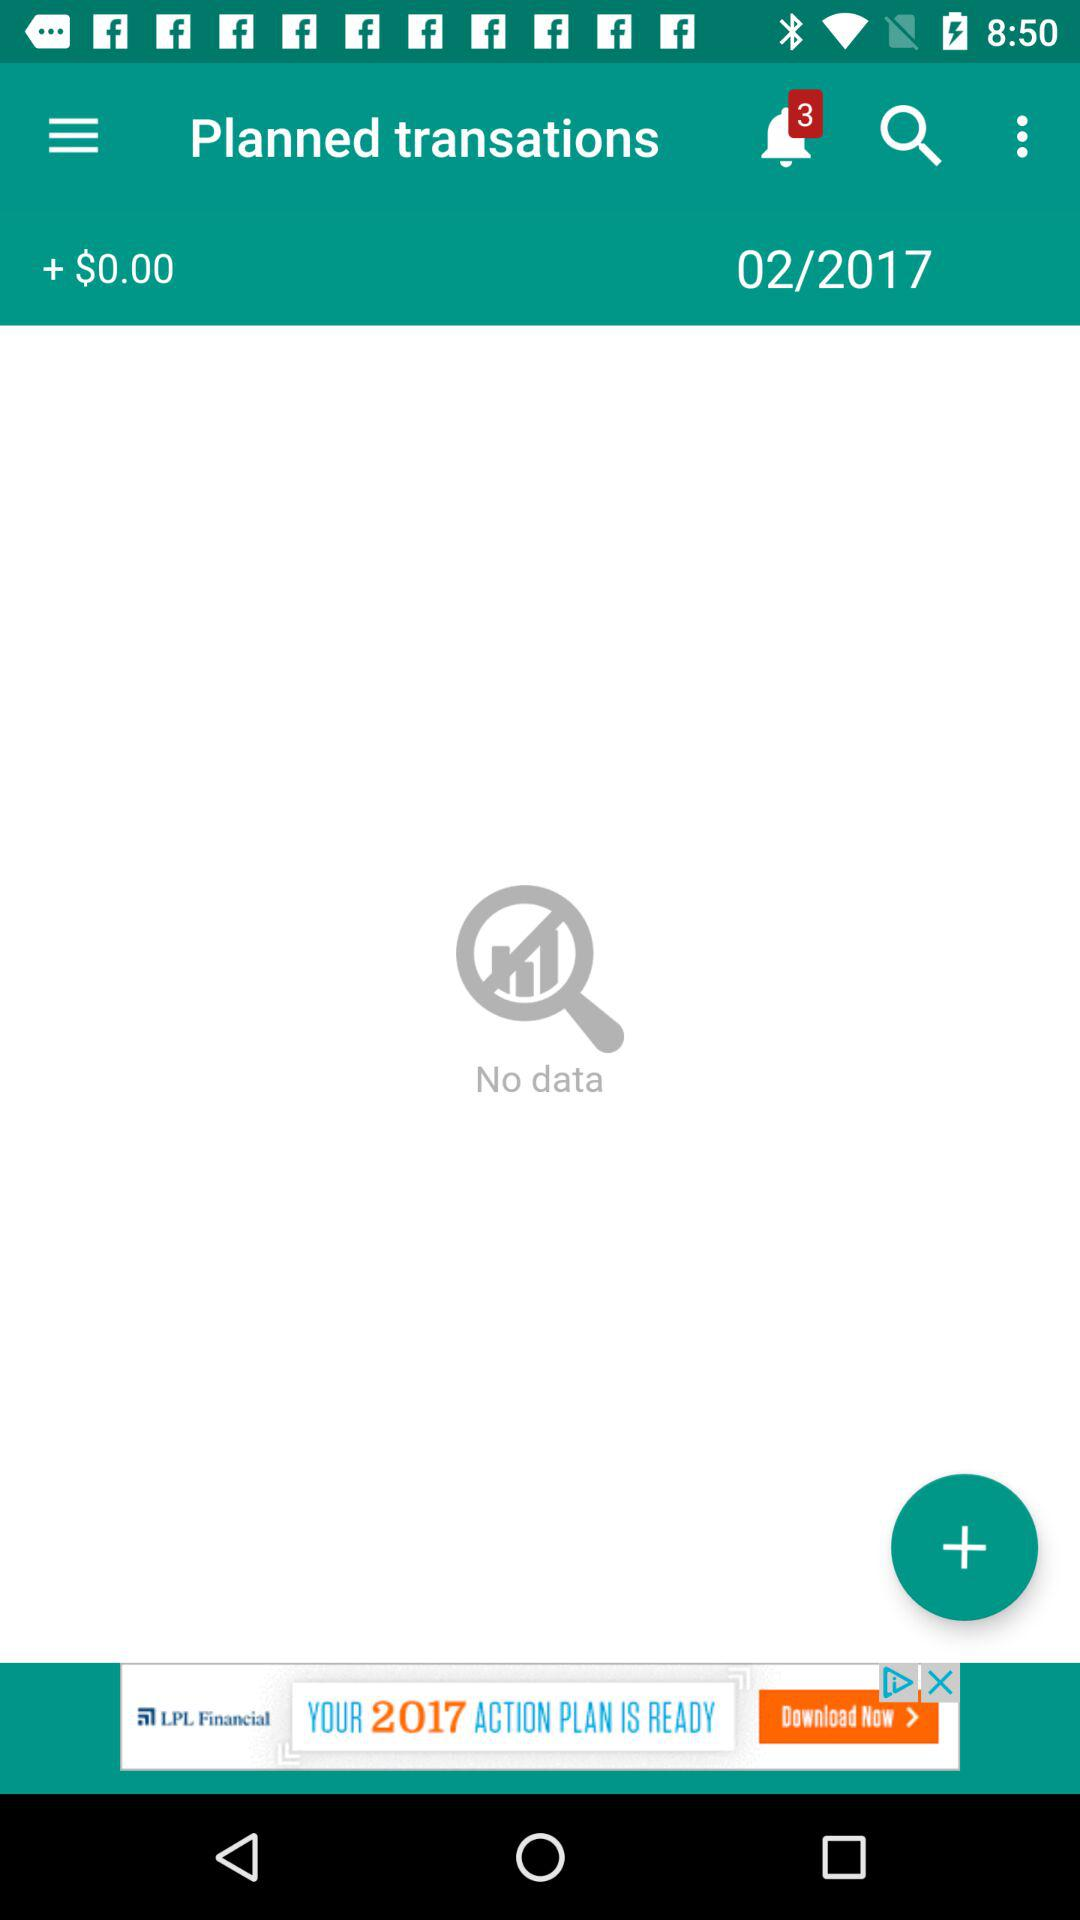How many notifications do I have?
Answer the question using a single word or phrase. 3 